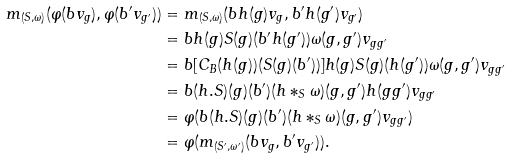Convert formula to latex. <formula><loc_0><loc_0><loc_500><loc_500>m _ { ( S , \omega ) } ( \varphi ( b v _ { g } ) , \varphi ( b ^ { \prime } v _ { g ^ { \prime } } ) ) & = m _ { ( S , \omega ) } ( b h ( g ) v _ { g } , b ^ { \prime } h ( g ^ { \prime } ) v _ { g ^ { \prime } } ) \\ & = b h ( { g } ) S ( { g } ) ( b ^ { \prime } h ( g ^ { \prime } ) ) \omega ( { g } , g ^ { \prime } ) v _ { g g ^ { \prime } } \\ & = b [ C _ { B } ( h ( { g } ) ) ( S ( { g } ) ( b ^ { \prime } ) ) ] h ( { g } ) S ( { g } ) ( h ( g ^ { \prime } ) ) \omega ( { g } , g ^ { \prime } ) v _ { g g ^ { \prime } } \\ & = b ( h . S ) ( { g } ) ( b ^ { \prime } ) ( h \ast _ { S } \omega ) ( { g } , g ^ { \prime } ) h ( { g g ^ { \prime } } ) v _ { g g ^ { \prime } } \\ & = \varphi ( b ( h . S ) ( { g } ) ( b ^ { \prime } ) ( h \ast _ { S } \omega ) ( { g } , { g ^ { \prime } } ) v _ { g g ^ { \prime } } ) \\ & = \varphi ( m _ { ( S ^ { \prime } , \omega ^ { \prime } ) } ( b v _ { g } , b ^ { \prime } v _ { g ^ { \prime } } ) ) .</formula> 